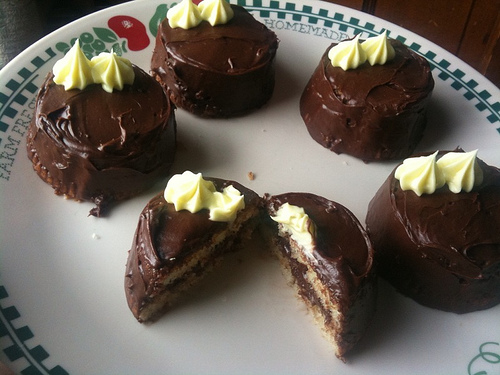<image>
Is the cake on the table? Yes. Looking at the image, I can see the cake is positioned on top of the table, with the table providing support. Is there a homemade on the plate? Yes. Looking at the image, I can see the homemade is positioned on top of the plate, with the plate providing support. 